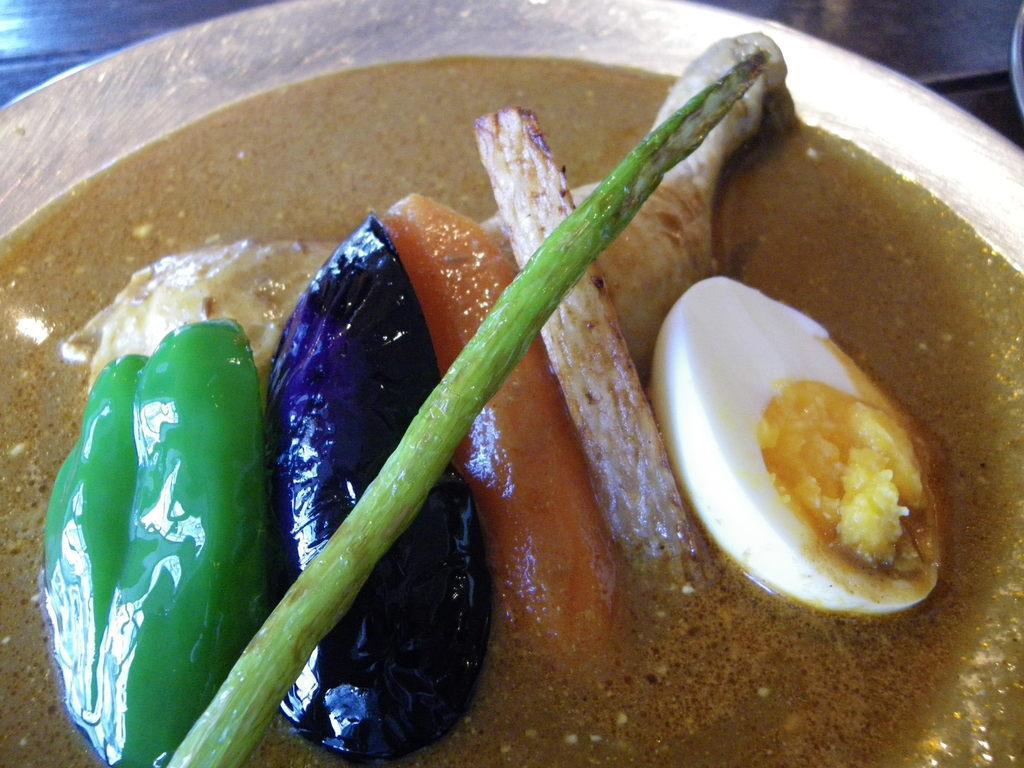How would you summarize this image in a sentence or two? In this picture we can see some eatable item placed in a plate. 